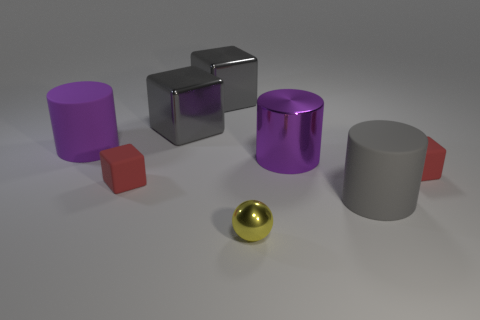There is a gray object that is in front of the tiny red object on the right side of the gray rubber cylinder; what size is it?
Keep it short and to the point. Large. Do the yellow metal object and the purple metallic cylinder have the same size?
Provide a short and direct response. No. There is a big object in front of the matte block left of the yellow thing; are there any red matte cubes that are in front of it?
Your answer should be compact. No. How big is the yellow metal object?
Make the answer very short. Small. What number of matte objects are the same size as the purple metallic cylinder?
Your response must be concise. 2. There is a big gray object that is the same shape as the big purple metal thing; what is it made of?
Offer a terse response. Rubber. The thing that is behind the gray cylinder and to the right of the large purple metallic cylinder has what shape?
Offer a very short reply. Cube. There is a red matte object that is right of the tiny metal thing; what shape is it?
Provide a succinct answer. Cube. How many big objects are behind the gray matte cylinder and in front of the purple matte thing?
Provide a succinct answer. 1. Is the size of the gray matte cylinder the same as the purple cylinder in front of the large purple matte cylinder?
Your answer should be very brief. Yes. 